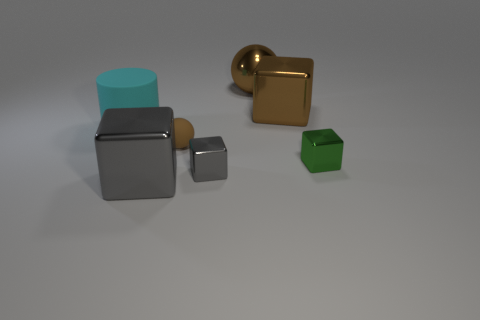There is a shiny thing that is the same color as the large sphere; what is its shape? cube 